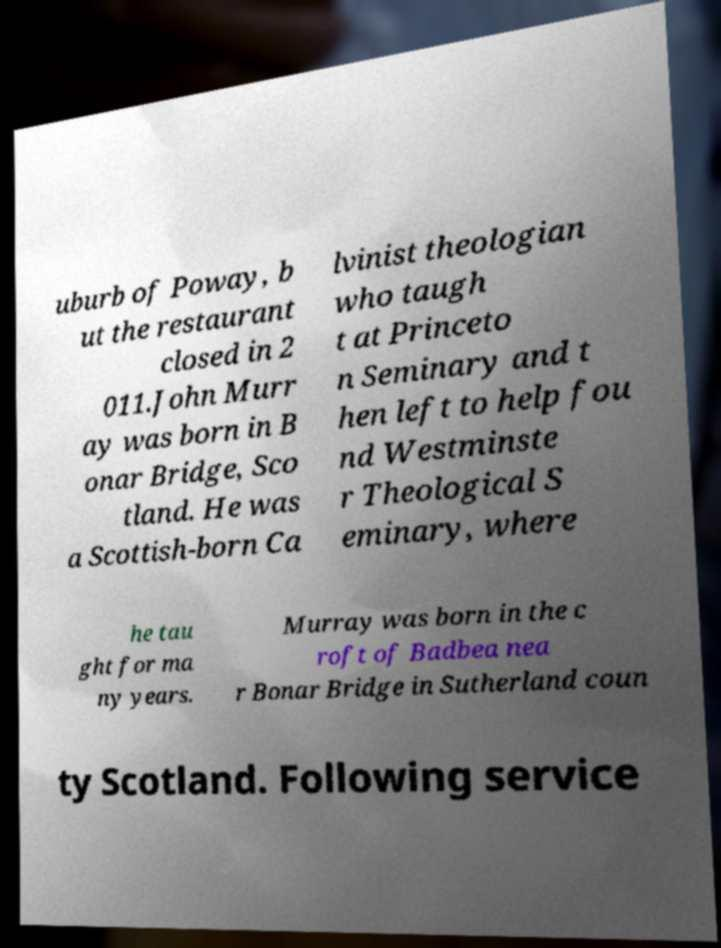For documentation purposes, I need the text within this image transcribed. Could you provide that? uburb of Poway, b ut the restaurant closed in 2 011.John Murr ay was born in B onar Bridge, Sco tland. He was a Scottish-born Ca lvinist theologian who taugh t at Princeto n Seminary and t hen left to help fou nd Westminste r Theological S eminary, where he tau ght for ma ny years. Murray was born in the c roft of Badbea nea r Bonar Bridge in Sutherland coun ty Scotland. Following service 